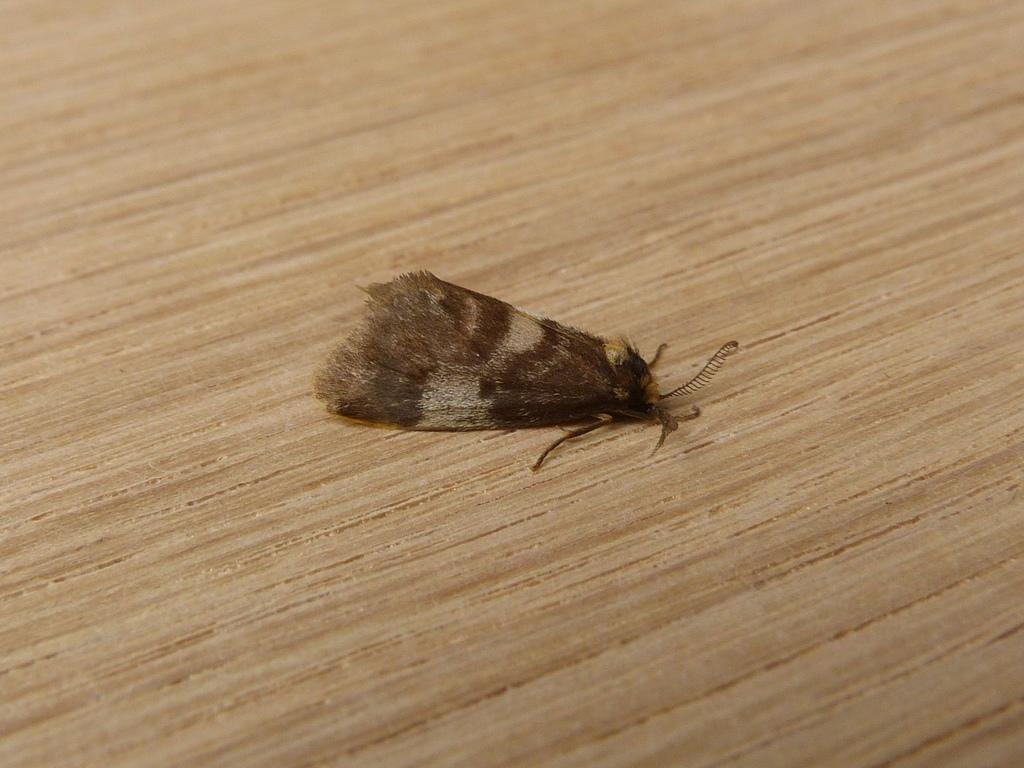Describe this image in one or two sentences. In this picture we can see a moth in the middle, there is a wooden surface at the bottom. 